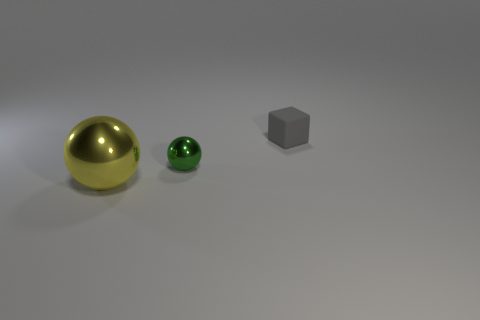Are there any other things that have the same material as the gray cube?
Your answer should be very brief. No. What is the shape of the small thing that is in front of the small gray rubber object?
Offer a very short reply. Sphere. What number of yellow shiny objects are the same size as the green metallic object?
Your answer should be compact. 0. The tiny sphere is what color?
Make the answer very short. Green. There is a large metal ball; is it the same color as the tiny object behind the small ball?
Offer a very short reply. No. What size is the green sphere that is made of the same material as the big yellow object?
Keep it short and to the point. Small. Are there any big things of the same color as the big metal sphere?
Make the answer very short. No. How many objects are metal objects behind the yellow shiny ball or rubber things?
Make the answer very short. 2. Are the yellow ball and the tiny thing that is behind the small green metal sphere made of the same material?
Make the answer very short. No. Are there any cylinders made of the same material as the yellow object?
Provide a short and direct response. No. 